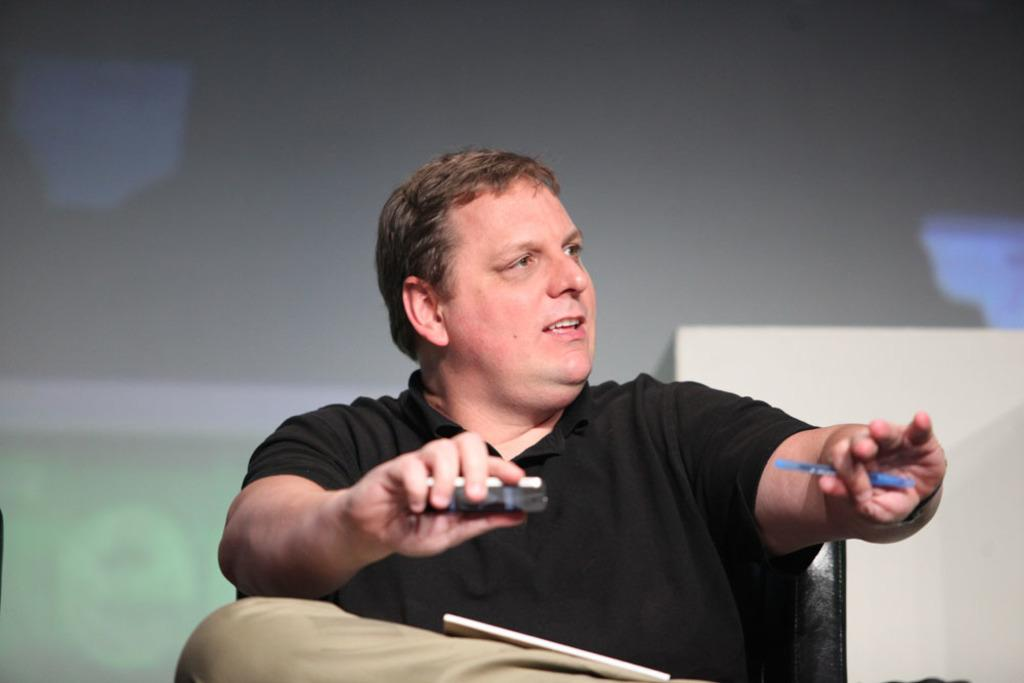Who is present in the image? There is a man in the picture. What is the man doing in the image? The man is sitting on a chair. What is the man holding in his hand? The man is holding two objects in his hand. What is the man using to read or study in the image? There is a book in the man's lap. What can be seen in the background of the picture? There is a screen in the background of the picture. Can you see the man swimming in the image? No, the man is sitting on a chair and there is no water or swimming activity depicted in the image. 